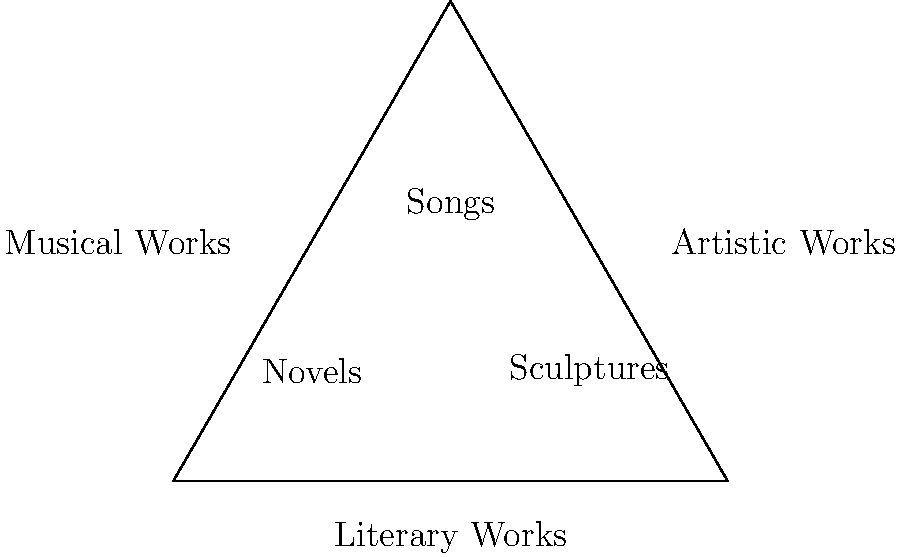As a parent of a young prodigy, you want to help your child understand how different types of creative works are protected by copyright laws. Using the Venn diagram above, which represents the intersection of Literary, Musical, and Artistic works, explain why "Songs" are placed at the center of the diagram and what this placement signifies in terms of copyright protection. To understand the placement of "Songs" in the Venn diagram and its significance for copyright protection, let's break it down step-by-step:

1. The Venn diagram shows three overlapping circles representing Literary Works, Musical Works, and Artistic Works.

2. "Songs" are placed at the center where all three circles intersect.

3. This central placement indicates that songs typically incorporate elements from all three categories:
   a) Literary Works: Song lyrics are considered literary works.
   b) Musical Works: The melody and harmony of a song are musical works.
   c) Artistic Works: The overall composition and arrangement can be considered an artistic work.

4. The circle in the center is labeled "All protected by copyright," which means that songs, as a combination of these elements, are fully protected under copyright law.

5. This comprehensive protection covers:
   - The written lyrics (literary aspect)
   - The musical composition (musical aspect)
   - The arrangement and production (artistic aspect)

6. Copyright protection for songs typically includes:
   - Right to reproduce the work
   - Right to distribute copies
   - Right to perform the work publicly
   - Right to create derivative works

7. For a young prodigy creating songs, this means their creations are protected in multiple ways, safeguarding their intellectual property across various aspects of the work.
Answer: Songs are at the center because they combine elements of literary, musical, and artistic works, receiving comprehensive copyright protection for all these aspects. 